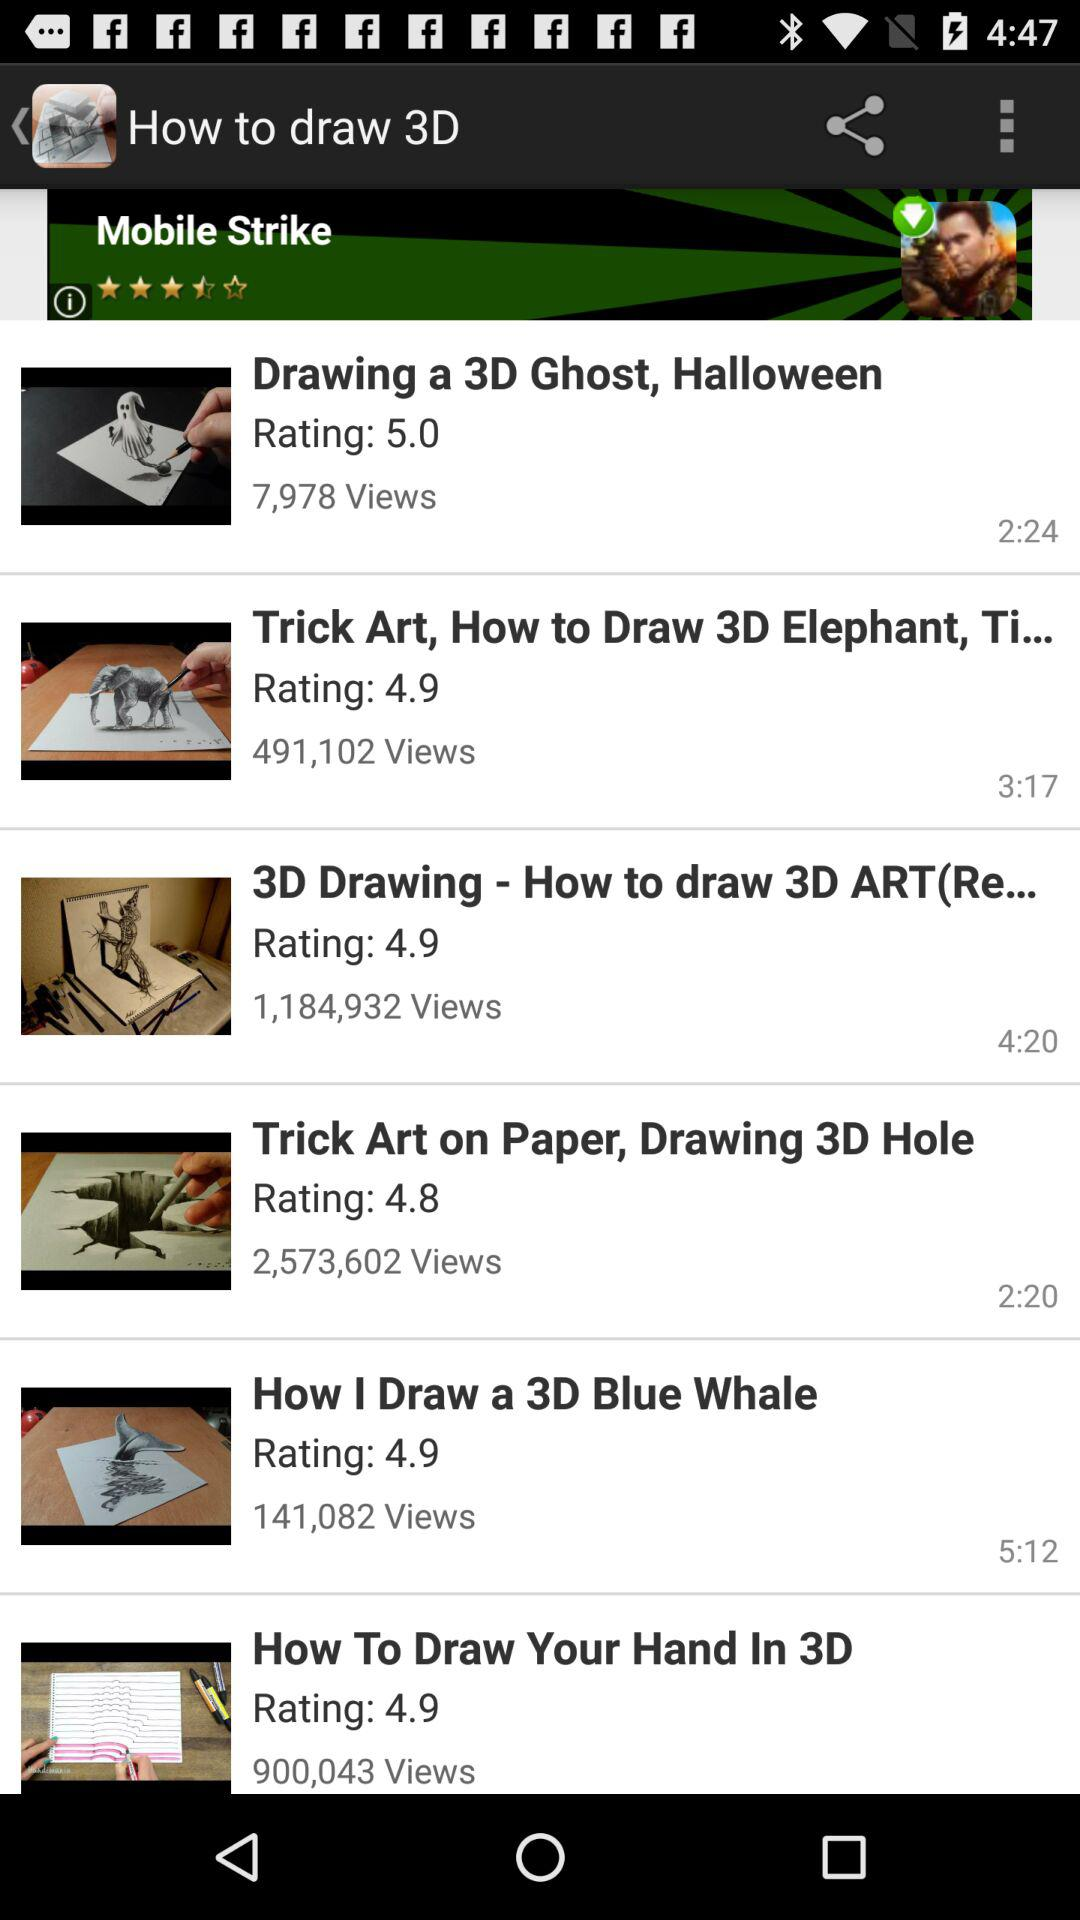What is the rating of 3D Ghost, Halloween? The rating is 5.0. 